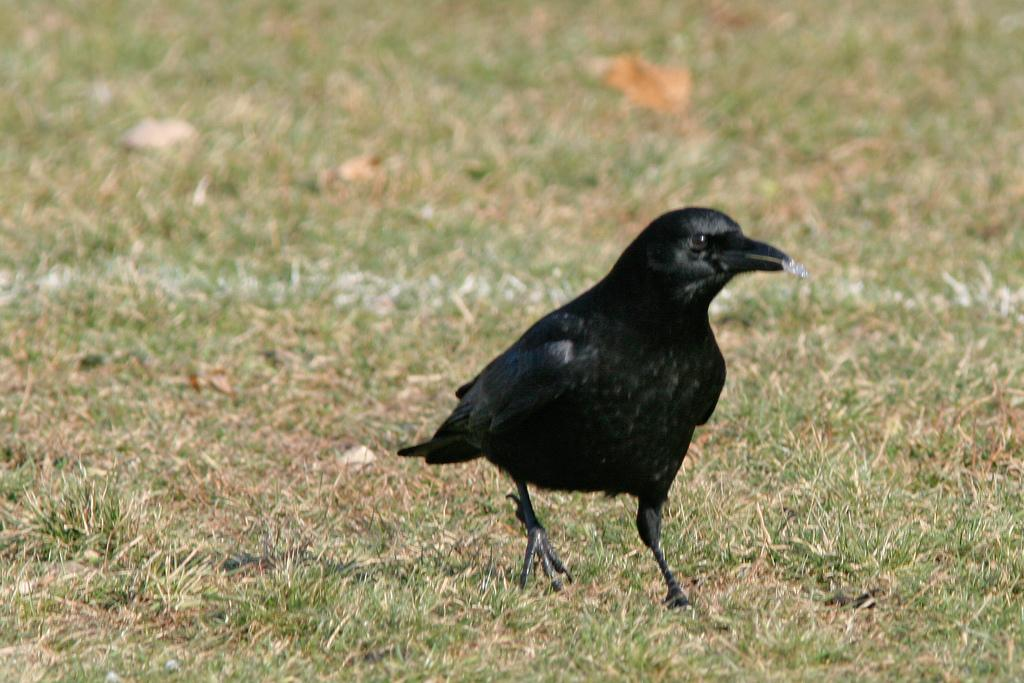What animal can be seen in the image? There is a crow in the image. Where is the crow located? The crow is on the ground. What is the crow holding in its mouth? The crow has food in its mouth. What type of vegetation is present on the ground? There is green grass on the ground. What else can be found on the ground in the image? There are objects on the ground. What type of amusement can be seen in the image? There is no amusement present in the image; it features a crow with food on the ground. Can you tell me how many farmers are visible in the image? There are no farmers present in the image. 